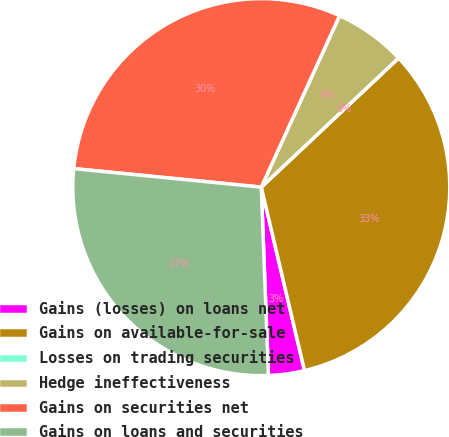Convert chart. <chart><loc_0><loc_0><loc_500><loc_500><pie_chart><fcel>Gains (losses) on loans net<fcel>Gains on available-for-sale<fcel>Losses on trading securities<fcel>Hedge ineffectiveness<fcel>Gains on securities net<fcel>Gains on loans and securities<nl><fcel>3.08%<fcel>33.33%<fcel>0.0%<fcel>6.17%<fcel>30.25%<fcel>27.17%<nl></chart> 